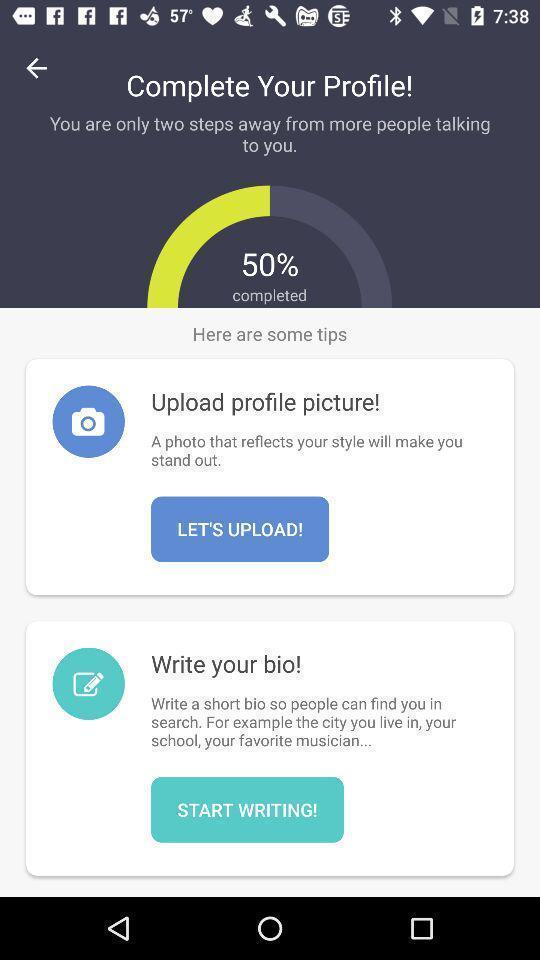Give me a summary of this screen capture. Screen shows profile details in a social application. 